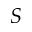Convert formula to latex. <formula><loc_0><loc_0><loc_500><loc_500>S</formula> 